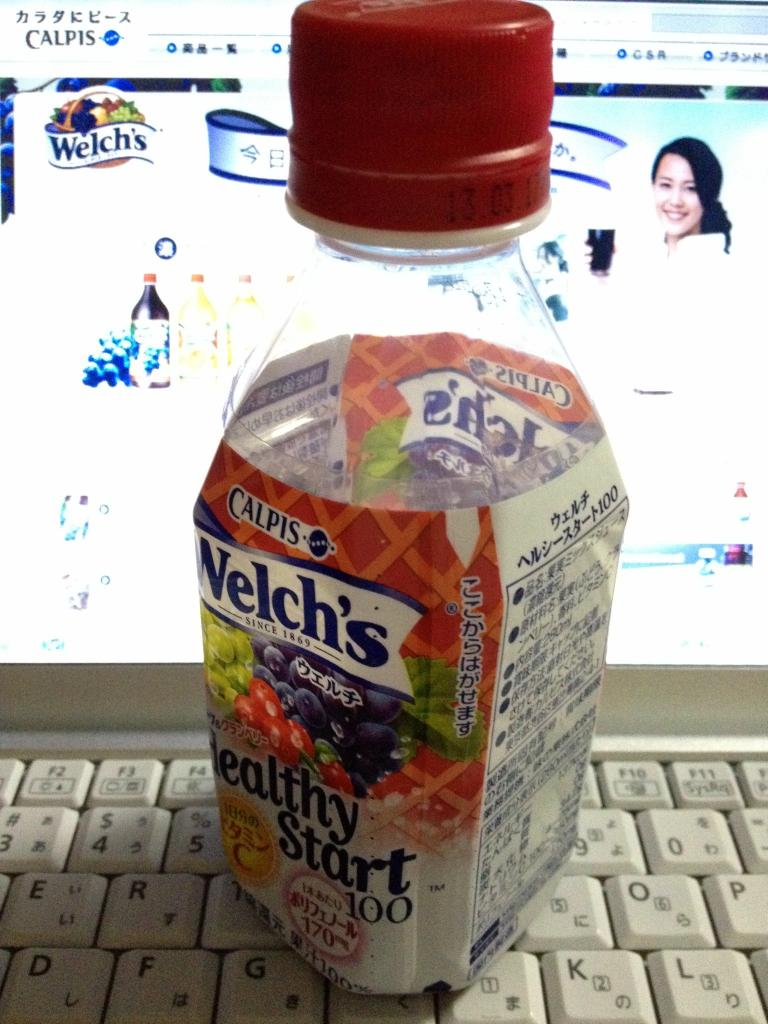Provide a one-sentence caption for the provided image. A bottle of Welch's 'Healthy Start 100' fruit juice prominently labeled in Japanese, rests against a backdrop of a computer keyboard, featuring an online shopping page for drinks. 